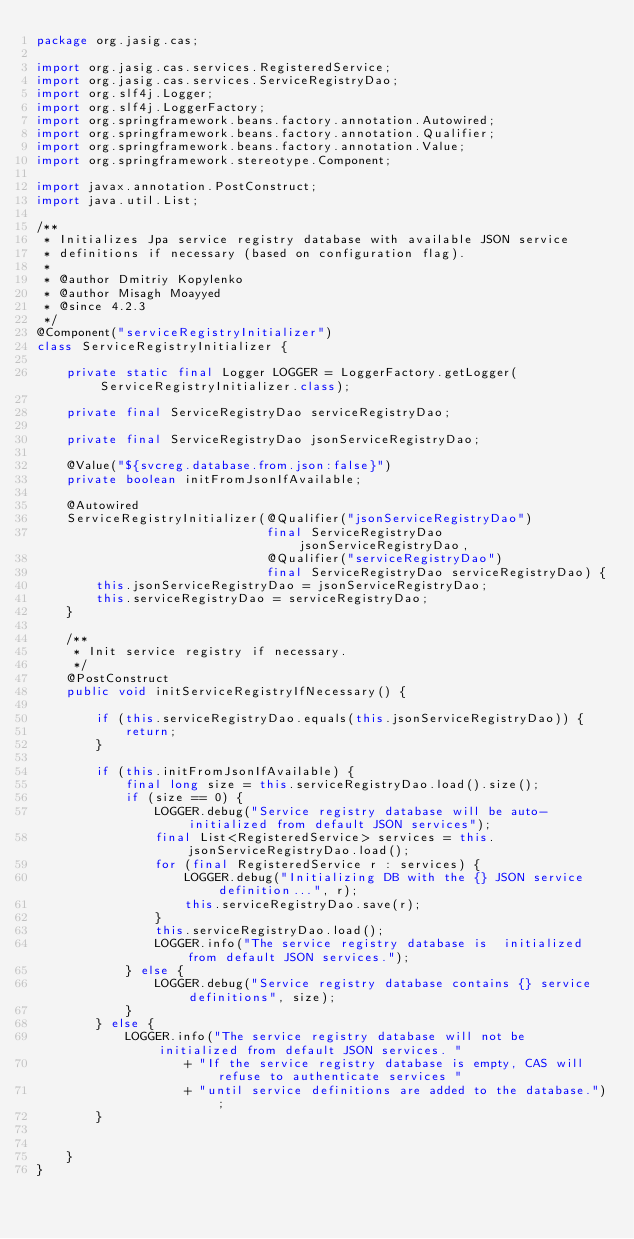<code> <loc_0><loc_0><loc_500><loc_500><_Java_>package org.jasig.cas;

import org.jasig.cas.services.RegisteredService;
import org.jasig.cas.services.ServiceRegistryDao;
import org.slf4j.Logger;
import org.slf4j.LoggerFactory;
import org.springframework.beans.factory.annotation.Autowired;
import org.springframework.beans.factory.annotation.Qualifier;
import org.springframework.beans.factory.annotation.Value;
import org.springframework.stereotype.Component;

import javax.annotation.PostConstruct;
import java.util.List;

/**
 * Initializes Jpa service registry database with available JSON service
 * definitions if necessary (based on configuration flag).
 *
 * @author Dmitriy Kopylenko
 * @author Misagh Moayyed
 * @since 4.2.3
 */
@Component("serviceRegistryInitializer")
class ServiceRegistryInitializer {

    private static final Logger LOGGER = LoggerFactory.getLogger(ServiceRegistryInitializer.class);

    private final ServiceRegistryDao serviceRegistryDao;

    private final ServiceRegistryDao jsonServiceRegistryDao;

    @Value("${svcreg.database.from.json:false}")
    private boolean initFromJsonIfAvailable;

    @Autowired
    ServiceRegistryInitializer(@Qualifier("jsonServiceRegistryDao")
                               final ServiceRegistryDao jsonServiceRegistryDao,
                               @Qualifier("serviceRegistryDao")
                               final ServiceRegistryDao serviceRegistryDao) {
        this.jsonServiceRegistryDao = jsonServiceRegistryDao;
        this.serviceRegistryDao = serviceRegistryDao;
    }

    /**
     * Init service registry if necessary.
     */
    @PostConstruct
    public void initServiceRegistryIfNecessary() {

        if (this.serviceRegistryDao.equals(this.jsonServiceRegistryDao)) {
            return;
        }

        if (this.initFromJsonIfAvailable) {
            final long size = this.serviceRegistryDao.load().size();
            if (size == 0) {
                LOGGER.debug("Service registry database will be auto-initialized from default JSON services");
                final List<RegisteredService> services = this.jsonServiceRegistryDao.load();
                for (final RegisteredService r : services) {
                    LOGGER.debug("Initializing DB with the {} JSON service definition...", r);
                    this.serviceRegistryDao.save(r);
                }
                this.serviceRegistryDao.load();
                LOGGER.info("The service registry database is  initialized from default JSON services.");
            } else {
                LOGGER.debug("Service registry database contains {} service definitions", size);
            }
        } else {
            LOGGER.info("The service registry database will not be initialized from default JSON services. "
                    + "If the service registry database is empty, CAS will refuse to authenticate services "
                    + "until service definitions are added to the database.");
        }


    }
}
</code> 